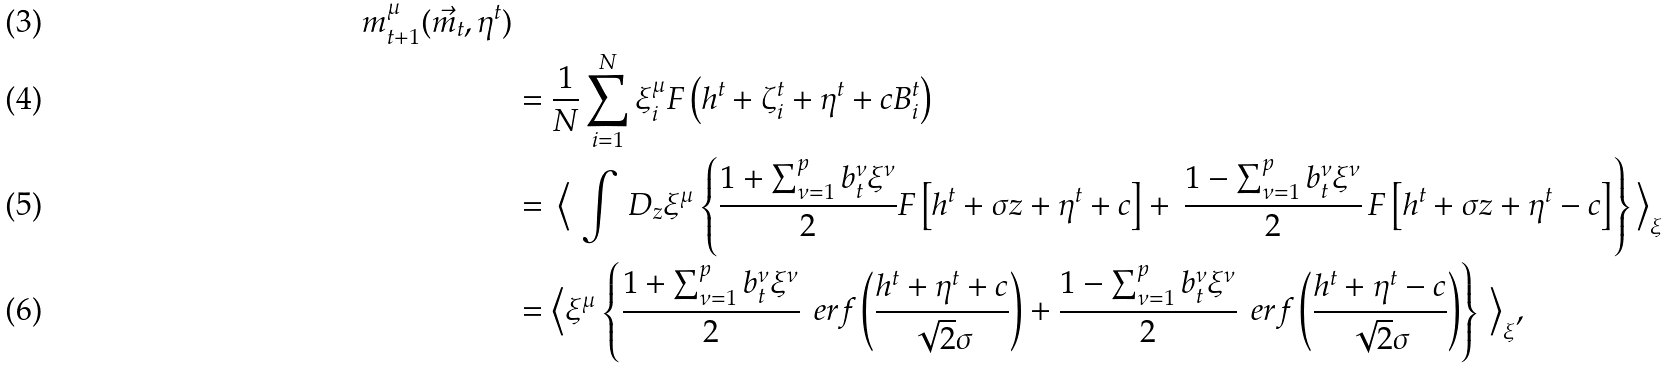<formula> <loc_0><loc_0><loc_500><loc_500>{ m ^ { \mu } _ { t + 1 } ( \vec { m } _ { t } , \eta ^ { t } ) } \\ & = \frac { 1 } { N } \sum _ { i = 1 } ^ { N } \xi ^ { \mu } _ { i } F \left ( h ^ { t } + \zeta ^ { t } _ { i } + \eta ^ { t } + c B ^ { t } _ { i } \right ) \\ & = \, \Big < \, \int \, D _ { z } \xi ^ { \mu } \left \{ \frac { 1 + \sum _ { \nu = 1 } ^ { p } b _ { t } ^ { \nu } \xi ^ { \nu } } { 2 } F \left [ h ^ { t } + \sigma z + \eta ^ { t } + c \right ] + \, \frac { 1 - \sum _ { \nu = 1 } ^ { p } b _ { t } ^ { \nu } \xi ^ { \nu } } { 2 } \, F \left [ h ^ { t } + \sigma z + \eta ^ { t } - c \right ] \right \} \Big > _ { \xi } \\ & = \Big < \xi ^ { \mu } \left \{ \frac { 1 + \sum _ { \nu = 1 } ^ { p } b _ { t } ^ { \nu } \xi ^ { \nu } } { 2 } \, \ e r f \left ( \frac { h ^ { t } + \eta ^ { t } + c } { \sqrt { 2 } \sigma } \right ) + \frac { 1 - \sum _ { \nu = 1 } ^ { p } b _ { t } ^ { \nu } \xi ^ { \nu } } { 2 } \, \ e r f \left ( \frac { h ^ { t } + \eta ^ { t } - c } { \sqrt { 2 } \sigma } \right ) \right \} \, \Big > _ { \xi } ,</formula> 